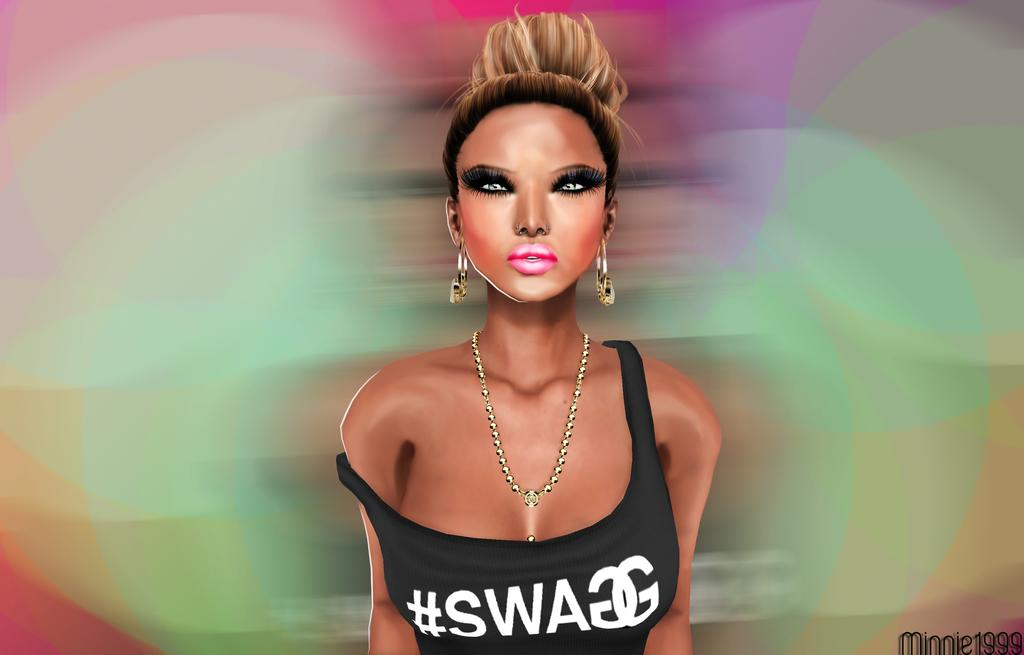Who is the main subject in the image? There is a girl in the image. What is the girl wearing on her upper body? The girl is wearing a black vest. What accessories is the girl wearing? The girl is wearing a necklace and earrings. Where is the girl positioned in the image? The girl is standing in the middle of the image. What can be observed about the background of the image? The background of the image features vibgyor colors. How does the girl use her mouth to hear in the image? The girl does not use her mouth to hear in the image; hearing is a function of the ears, not the mouth. 